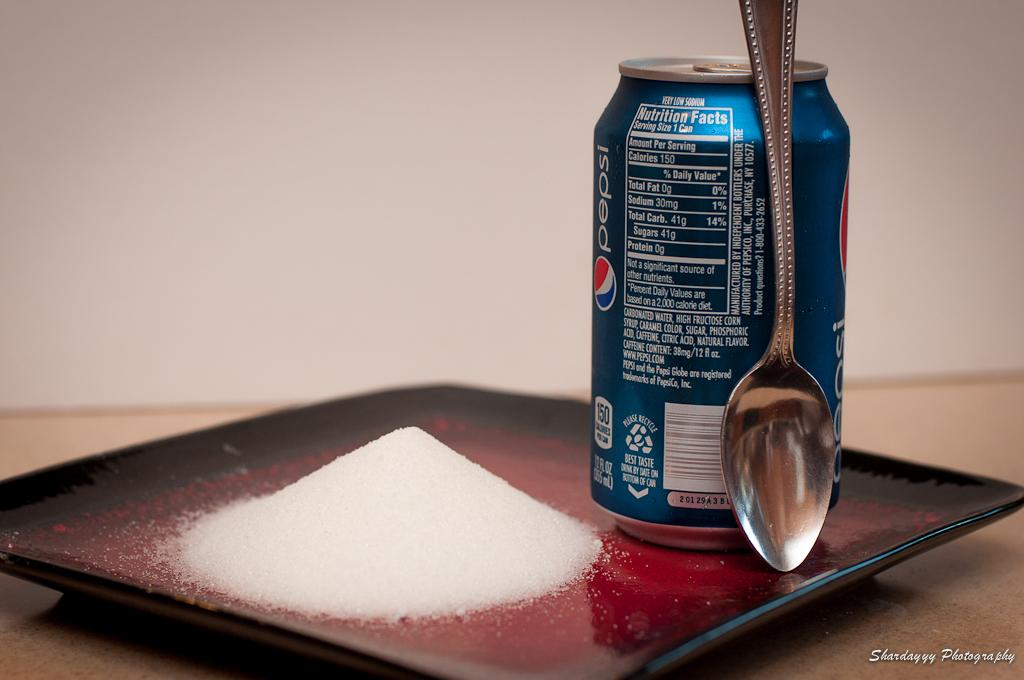Provide a one-sentence caption for the provided image. Photo of a can, a spoon, and sugar, demonstrating the amount of sugar in a Pepsi. 